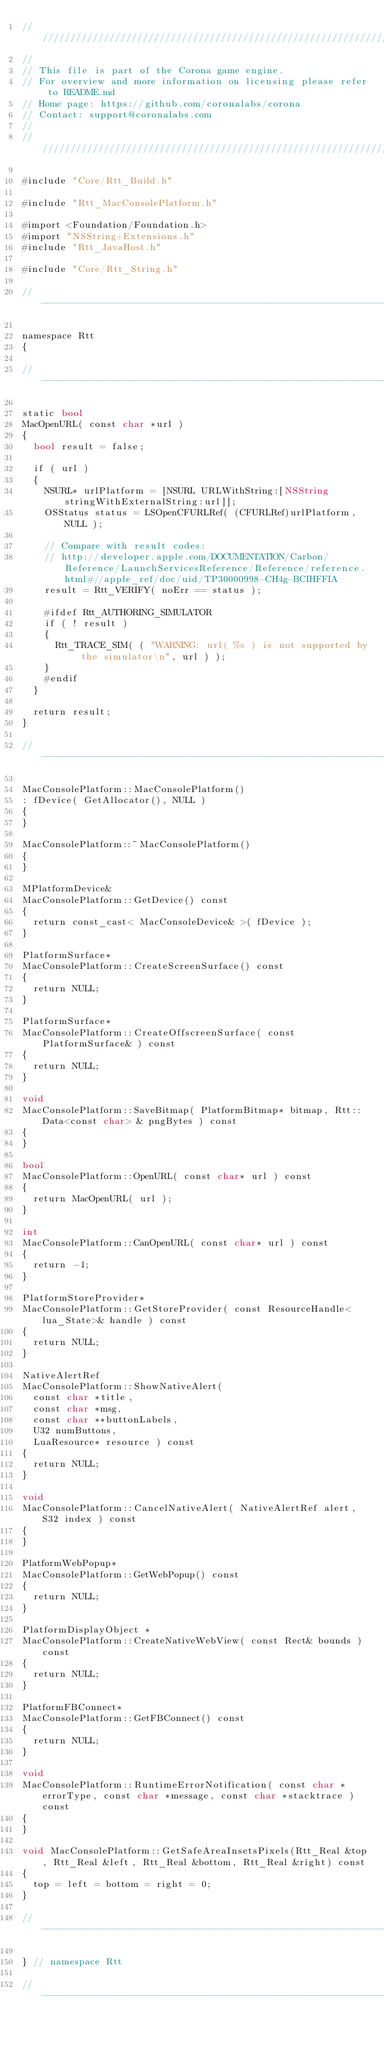Convert code to text. <code><loc_0><loc_0><loc_500><loc_500><_ObjectiveC_>//////////////////////////////////////////////////////////////////////////////
//
// This file is part of the Corona game engine.
// For overview and more information on licensing please refer to README.md 
// Home page: https://github.com/coronalabs/corona
// Contact: support@coronalabs.com
//
//////////////////////////////////////////////////////////////////////////////

#include "Core/Rtt_Build.h"

#include "Rtt_MacConsolePlatform.h"

#import <Foundation/Foundation.h>
#import "NSString+Extensions.h"
#include "Rtt_JavaHost.h"

#include "Core/Rtt_String.h"

// ----------------------------------------------------------------------------

namespace Rtt
{

// ----------------------------------------------------------------------------

static bool
MacOpenURL( const char *url )
{
	bool result = false;

	if ( url )
	{
		NSURL* urlPlatform = [NSURL URLWithString:[NSString stringWithExternalString:url]];
		OSStatus status = LSOpenCFURLRef( (CFURLRef)urlPlatform, NULL );

		// Compare with result codes:
		// http://developer.apple.com/DOCUMENTATION/Carbon/Reference/LaunchServicesReference/Reference/reference.html#//apple_ref/doc/uid/TP30000998-CH4g-BCIHFFIA
		result = Rtt_VERIFY( noErr == status );

		#ifdef Rtt_AUTHORING_SIMULATOR
		if ( ! result )
		{
			Rtt_TRACE_SIM( ( "WARNING: url( %s ) is not supported by the simulator\n", url ) );
		}
		#endif
	}

	return result;
}

// ----------------------------------------------------------------------------

MacConsolePlatform::MacConsolePlatform()
:	fDevice( GetAllocator(), NULL )
{
}

MacConsolePlatform::~MacConsolePlatform()
{
}
	
MPlatformDevice&
MacConsolePlatform::GetDevice() const
{
	return const_cast< MacConsoleDevice& >( fDevice );
}

PlatformSurface*
MacConsolePlatform::CreateScreenSurface() const
{
	return NULL;
}

PlatformSurface*
MacConsolePlatform::CreateOffscreenSurface( const PlatformSurface& ) const
{
	return NULL;
}

void
MacConsolePlatform::SaveBitmap( PlatformBitmap* bitmap, Rtt::Data<const char> & pngBytes ) const
{
}

bool
MacConsolePlatform::OpenURL( const char* url ) const
{
	return MacOpenURL( url );
}

int
MacConsolePlatform::CanOpenURL( const char* url ) const
{
	return -1;
}

PlatformStoreProvider*
MacConsolePlatform::GetStoreProvider( const ResourceHandle<lua_State>& handle ) const
{
	return NULL;
}

NativeAlertRef
MacConsolePlatform::ShowNativeAlert(
	const char *title,
	const char *msg,
	const char **buttonLabels,
	U32 numButtons,
	LuaResource* resource ) const
{
	return NULL;
}

void
MacConsolePlatform::CancelNativeAlert( NativeAlertRef alert, S32 index ) const
{
}

PlatformWebPopup*
MacConsolePlatform::GetWebPopup() const
{
	return NULL;
}

PlatformDisplayObject *
MacConsolePlatform::CreateNativeWebView( const Rect& bounds ) const
{
	return NULL;
}

PlatformFBConnect*
MacConsolePlatform::GetFBConnect() const
{
	return NULL;
}

void
MacConsolePlatform::RuntimeErrorNotification( const char *errorType, const char *message, const char *stacktrace ) const
{
}

void MacConsolePlatform::GetSafeAreaInsetsPixels(Rtt_Real &top, Rtt_Real &left, Rtt_Real &bottom, Rtt_Real &right) const
{
	top = left = bottom = right = 0;
}

// ----------------------------------------------------------------------------

} // namespace Rtt

// ----------------------------------------------------------------------------

</code> 